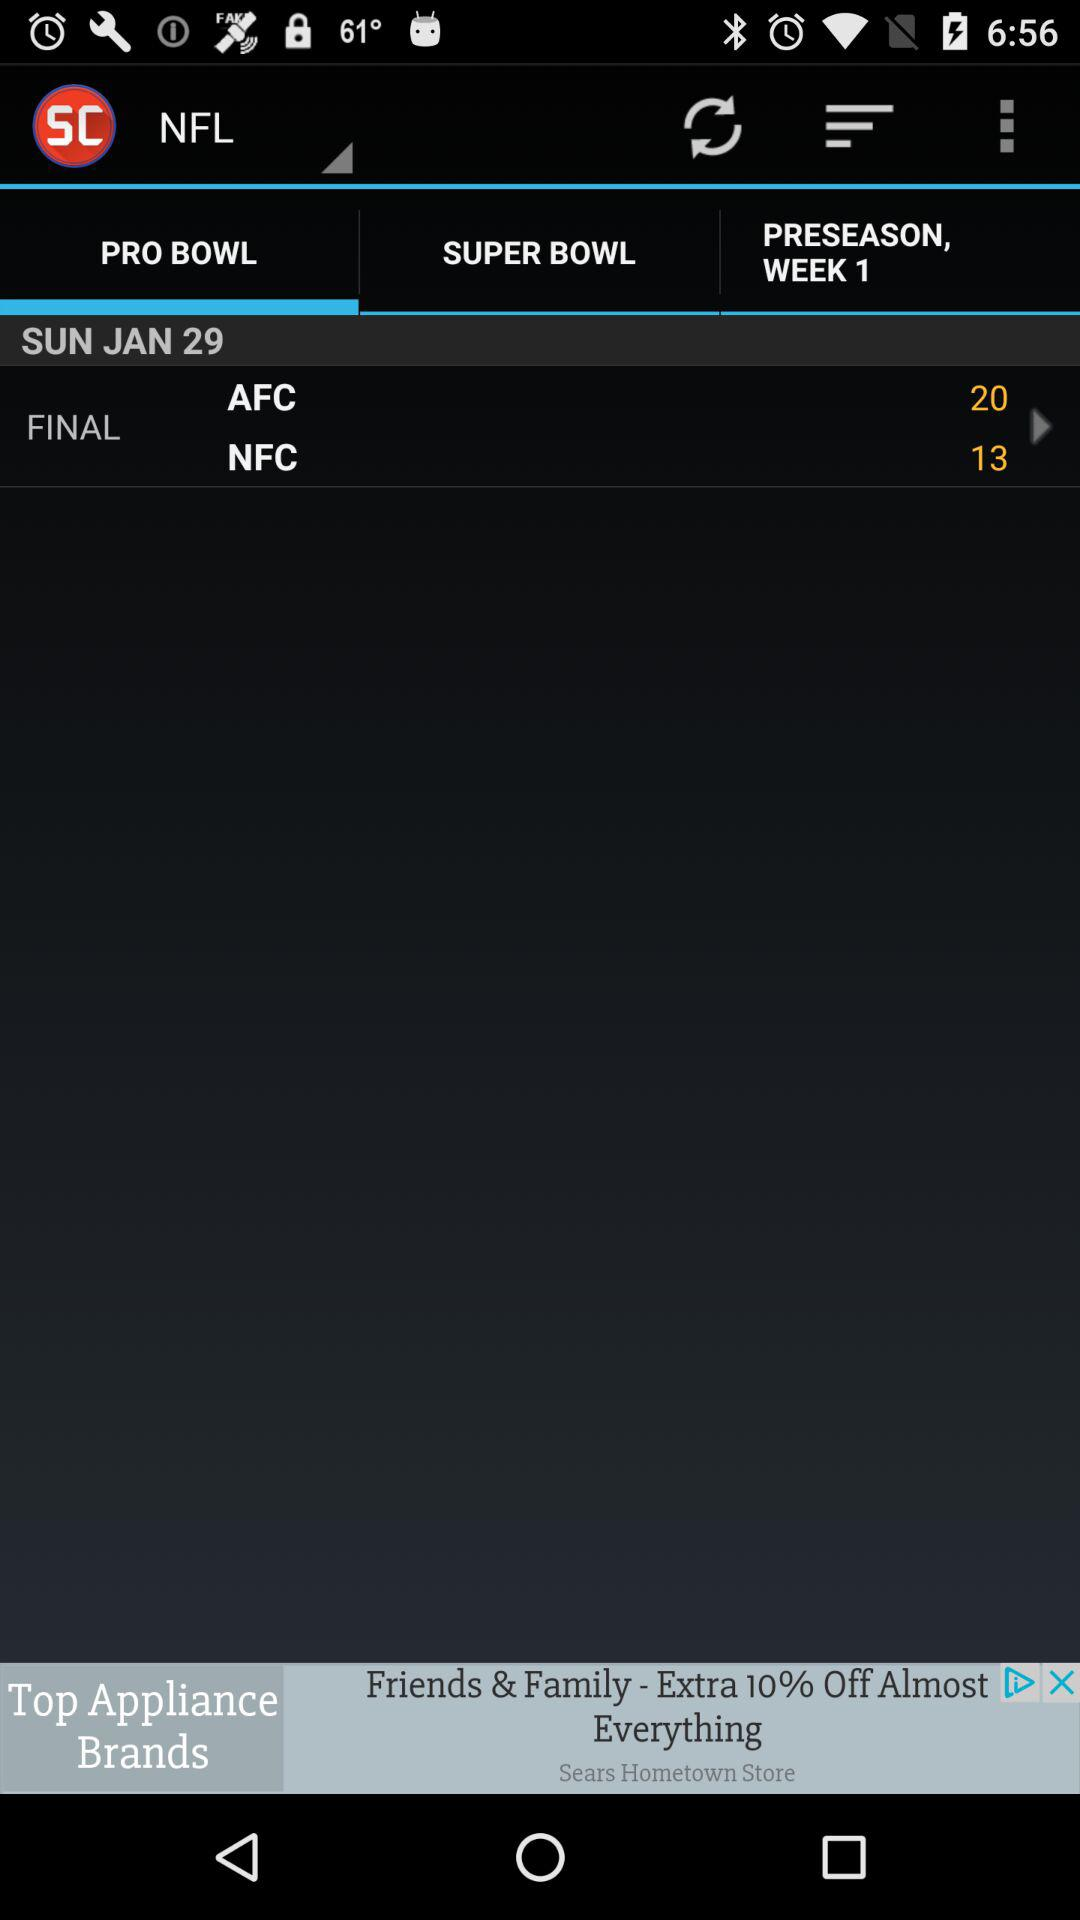How many more points did the AFC score than the NFC?
Answer the question using a single word or phrase. 7 